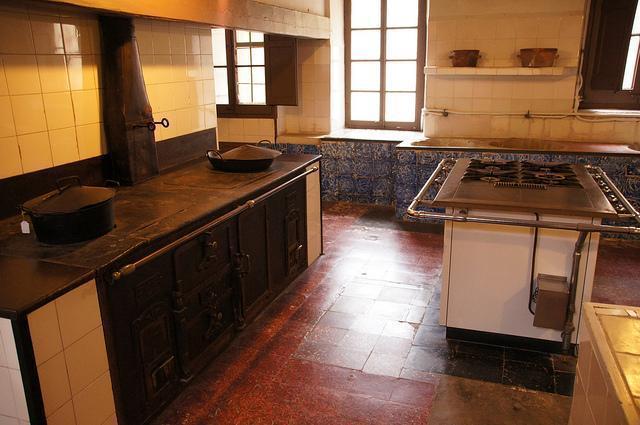Where would a kitchen like this be located?
Make your selection from the four choices given to correctly answer the question.
Options: Kitchenette, dorm room, restaurant, mountain cabin. Restaurant. 